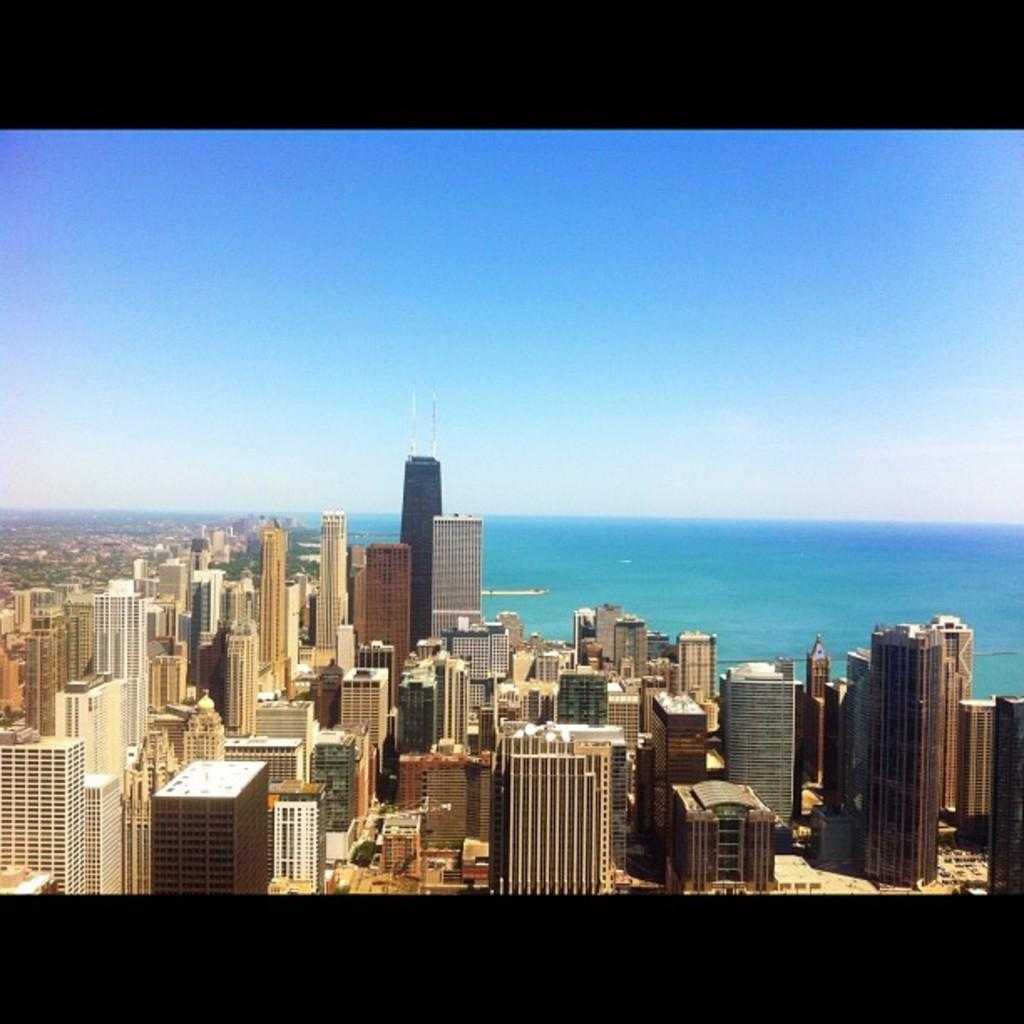What type of structures can be seen in the image? There are buildings in the image. What natural element is visible in the image? There is water visible in the image. What is the color of the sky in the image? The sky is blue in the image. What type of crayon is being used to draw on the buildings in the image? There is no crayon or drawing activity present in the image. How many trucks can be seen driving on the water in the image? There are no trucks visible in the image, and they cannot drive on water. 